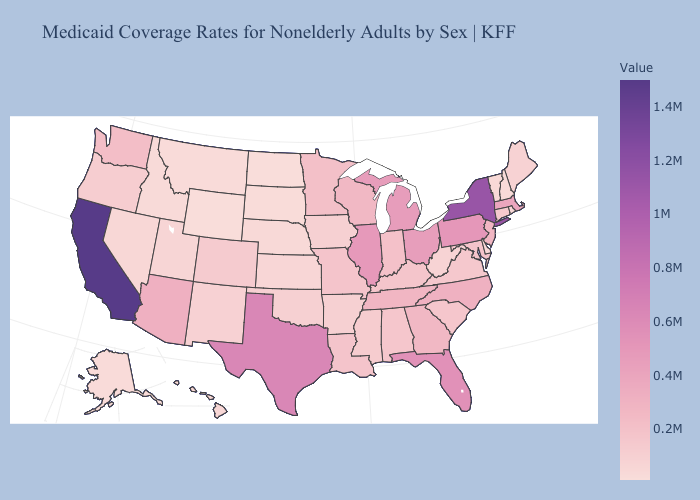Among the states that border Massachusetts , which have the lowest value?
Write a very short answer. New Hampshire. Does Georgia have the lowest value in the USA?
Be succinct. No. Does Montana have the highest value in the West?
Answer briefly. No. Which states have the highest value in the USA?
Short answer required. California. 